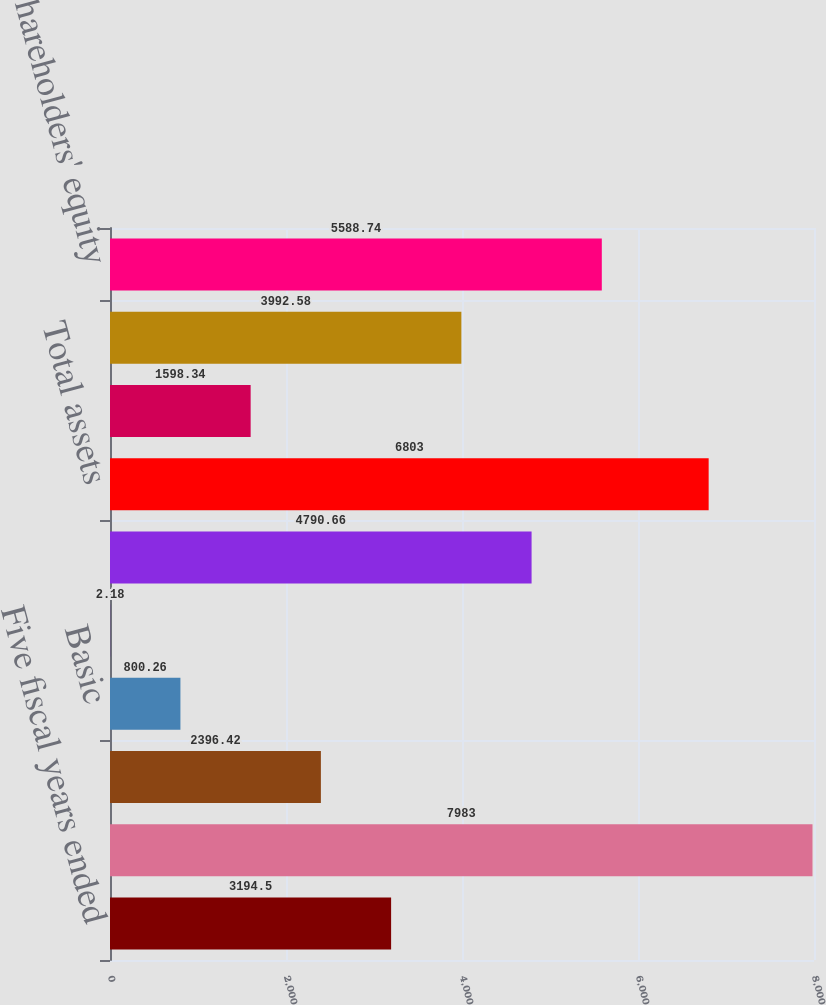<chart> <loc_0><loc_0><loc_500><loc_500><bar_chart><fcel>Five fiscal years ended<fcel>Net sales<fcel>Net income (loss)<fcel>Basic<fcel>Diluted<fcel>Cash cash equivalents and<fcel>Total assets<fcel>Long-term debt<fcel>Total liabilities<fcel>Shareholders' equity<nl><fcel>3194.5<fcel>7983<fcel>2396.42<fcel>800.26<fcel>2.18<fcel>4790.66<fcel>6803<fcel>1598.34<fcel>3992.58<fcel>5588.74<nl></chart> 